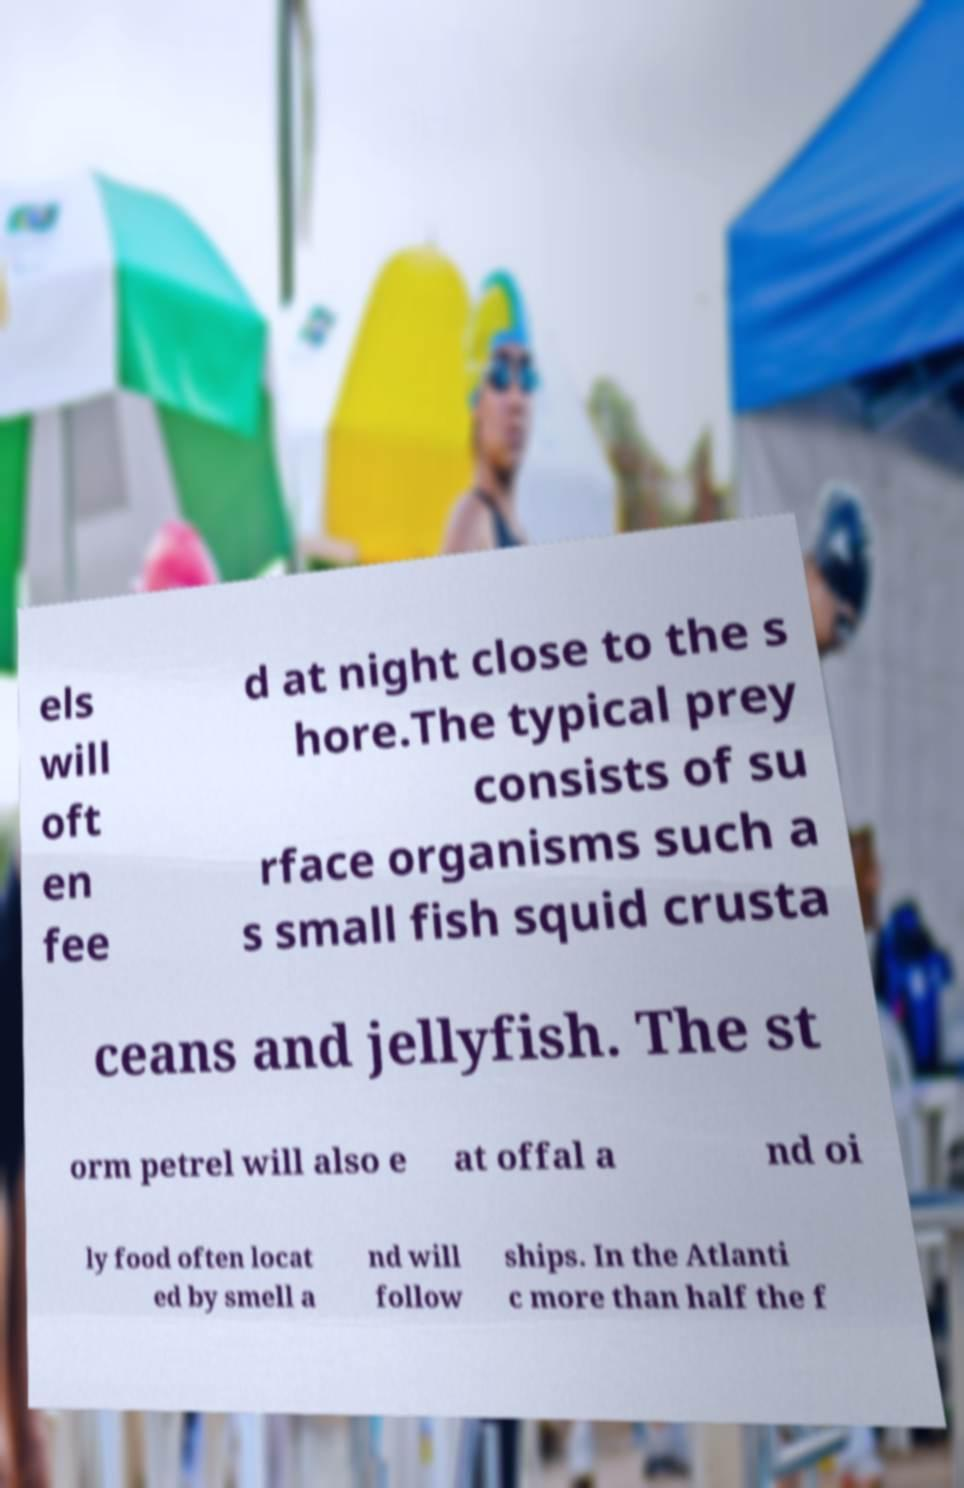Could you extract and type out the text from this image? els will oft en fee d at night close to the s hore.The typical prey consists of su rface organisms such a s small fish squid crusta ceans and jellyfish. The st orm petrel will also e at offal a nd oi ly food often locat ed by smell a nd will follow ships. In the Atlanti c more than half the f 